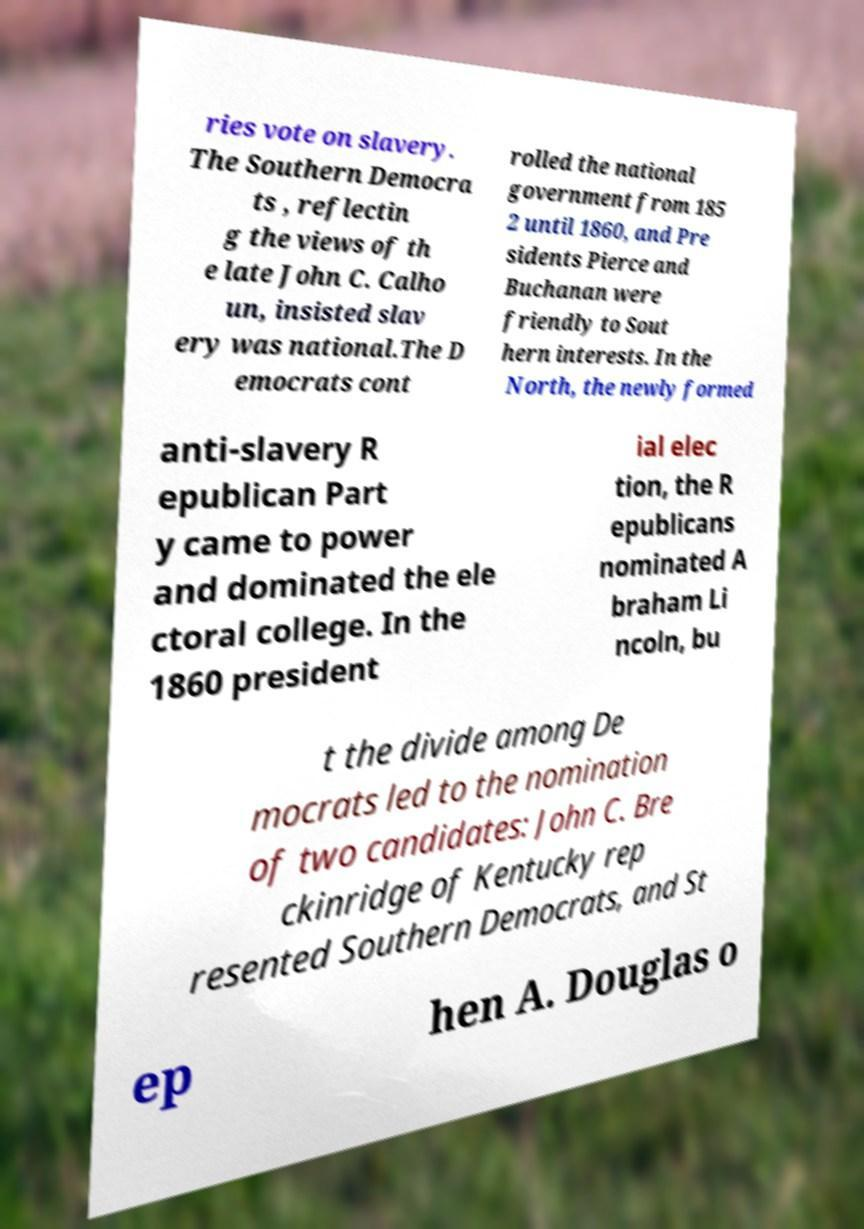Please identify and transcribe the text found in this image. ries vote on slavery. The Southern Democra ts , reflectin g the views of th e late John C. Calho un, insisted slav ery was national.The D emocrats cont rolled the national government from 185 2 until 1860, and Pre sidents Pierce and Buchanan were friendly to Sout hern interests. In the North, the newly formed anti-slavery R epublican Part y came to power and dominated the ele ctoral college. In the 1860 president ial elec tion, the R epublicans nominated A braham Li ncoln, bu t the divide among De mocrats led to the nomination of two candidates: John C. Bre ckinridge of Kentucky rep resented Southern Democrats, and St ep hen A. Douglas o 